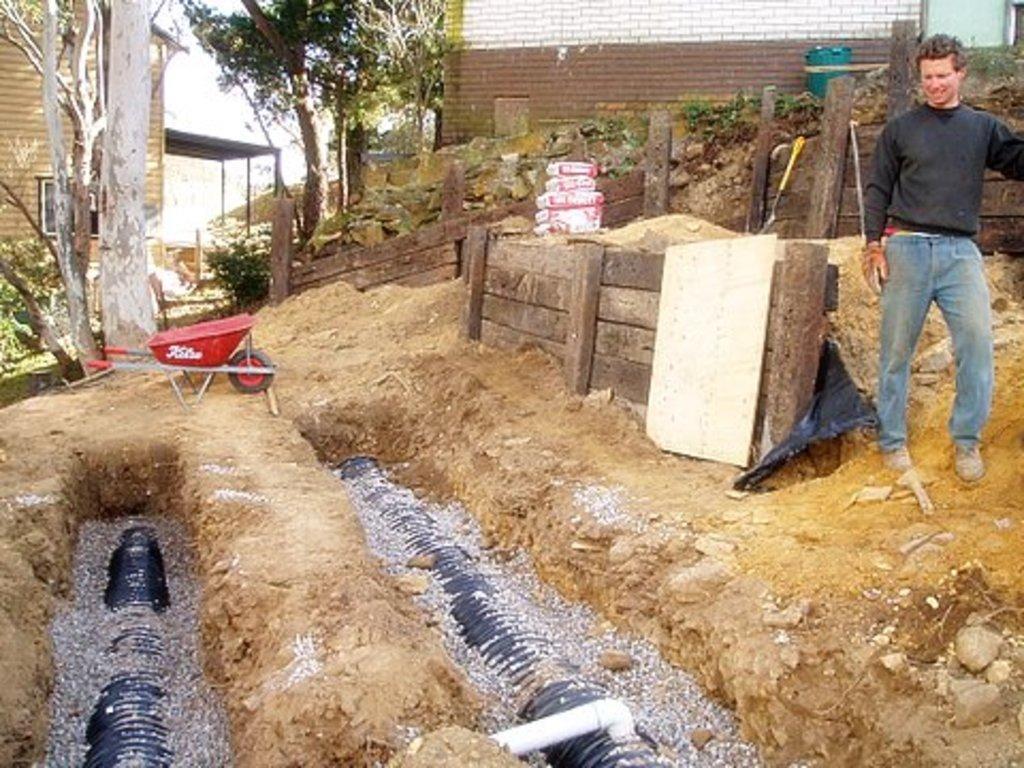How would you summarize this image in a sentence or two? In this picture I can see a person standing on the ground, in front we can see some pipe lines in the earth, around we can see some houses, trees, wooden tables and some boxes. 